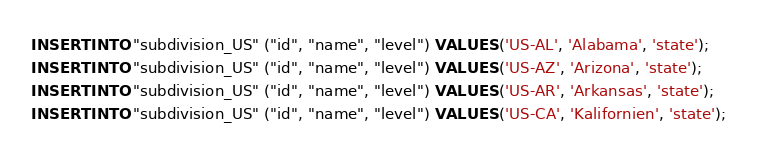Convert code to text. <code><loc_0><loc_0><loc_500><loc_500><_SQL_>INSERT INTO "subdivision_US" ("id", "name", "level") VALUES ('US-AL', 'Alabama', 'state');
INSERT INTO "subdivision_US" ("id", "name", "level") VALUES ('US-AZ', 'Arizona', 'state');
INSERT INTO "subdivision_US" ("id", "name", "level") VALUES ('US-AR', 'Arkansas', 'state');
INSERT INTO "subdivision_US" ("id", "name", "level") VALUES ('US-CA', 'Kalifornien', 'state');</code> 